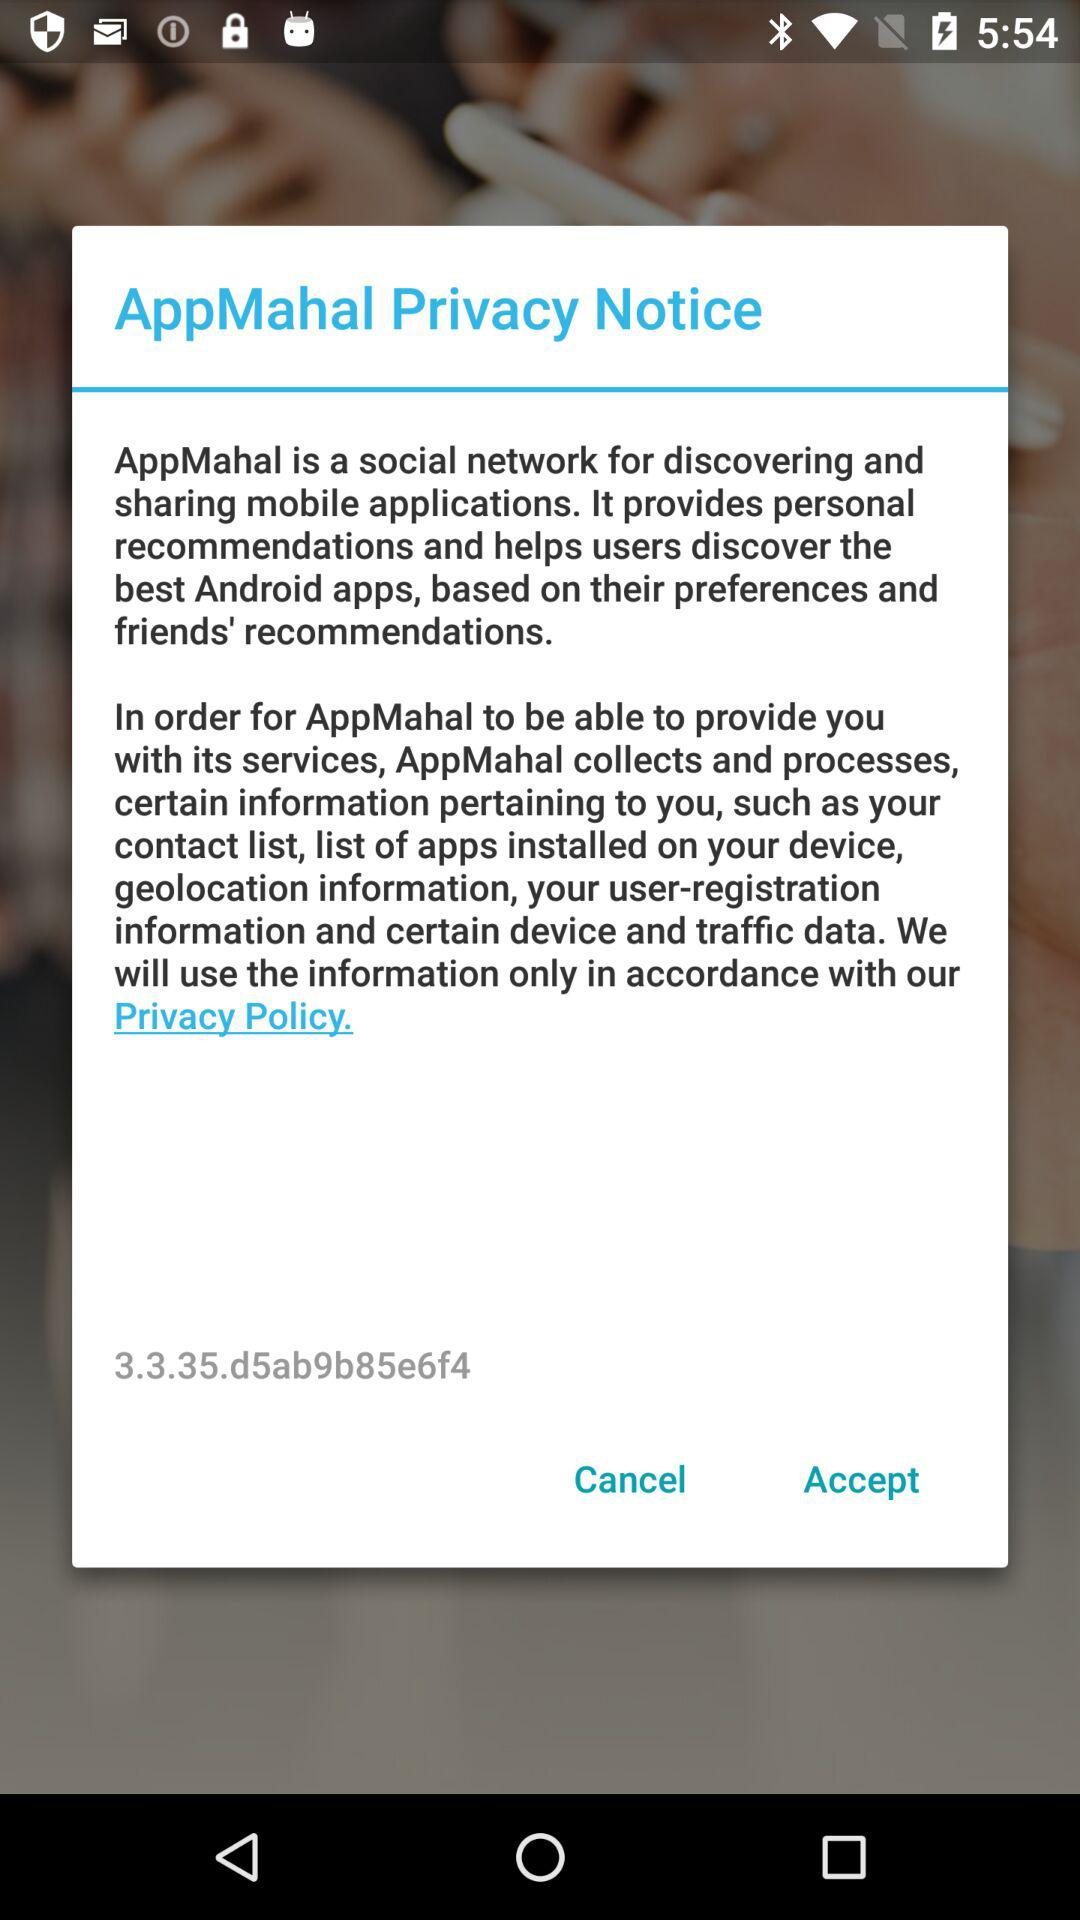What is AppMahal Privacy notice? The notice is AppMahal is a social network for discovering and sharing mobile applications. It provides personal recommendations and help users discover the best Android apps, based on their preferences and friend's recommendations. In order for AppMahal to be able to provide you with its services, AppMahal collects and processes, certain information pertaining to you, such as your contact list, list of apps installed on your device, geolocation information, your user-registration information and certain device and traffic data, We will use the information only in accordance with our Privacy Policy. 